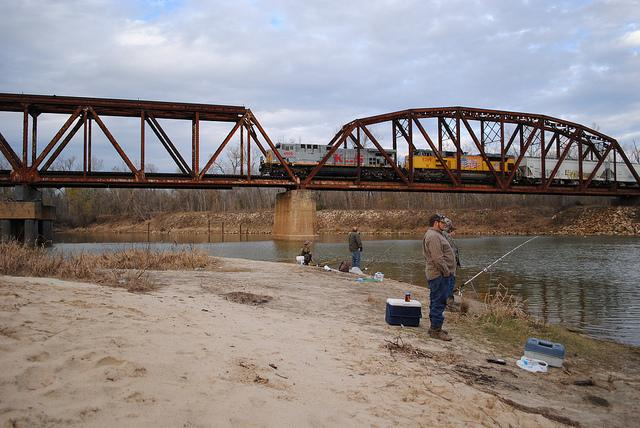What do the men hope to bring home? fish 